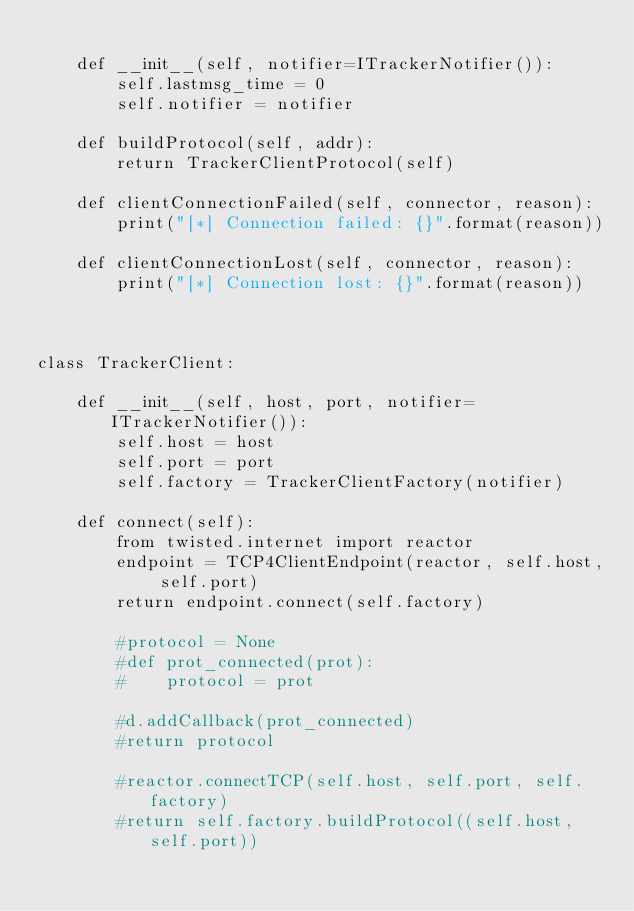Convert code to text. <code><loc_0><loc_0><loc_500><loc_500><_Python_>
    def __init__(self, notifier=ITrackerNotifier()):
        self.lastmsg_time = 0
        self.notifier = notifier

    def buildProtocol(self, addr):
        return TrackerClientProtocol(self)

    def clientConnectionFailed(self, connector, reason):
        print("[*] Connection failed: {}".format(reason))

    def clientConnectionLost(self, connector, reason):
        print("[*] Connection lost: {}".format(reason))



class TrackerClient:

    def __init__(self, host, port, notifier=ITrackerNotifier()):
        self.host = host
        self.port = port
        self.factory = TrackerClientFactory(notifier)

    def connect(self):
        from twisted.internet import reactor
        endpoint = TCP4ClientEndpoint(reactor, self.host, self.port)
        return endpoint.connect(self.factory)

        #protocol = None
        #def prot_connected(prot):
        #    protocol = prot

        #d.addCallback(prot_connected)
        #return protocol

        #reactor.connectTCP(self.host, self.port, self.factory)
        #return self.factory.buildProtocol((self.host, self.port))
</code> 